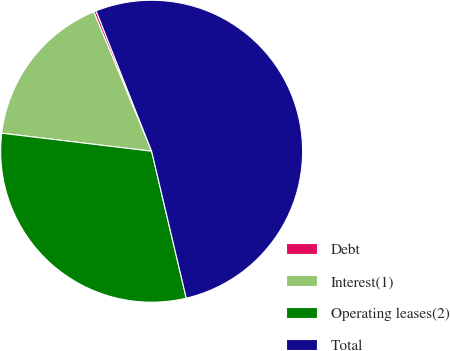Convert chart to OTSL. <chart><loc_0><loc_0><loc_500><loc_500><pie_chart><fcel>Debt<fcel>Interest(1)<fcel>Operating leases(2)<fcel>Total<nl><fcel>0.27%<fcel>16.83%<fcel>30.59%<fcel>52.31%<nl></chart> 